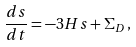<formula> <loc_0><loc_0><loc_500><loc_500>\frac { d s } { d t } = - 3 H s + \Sigma _ { D } \, ,</formula> 